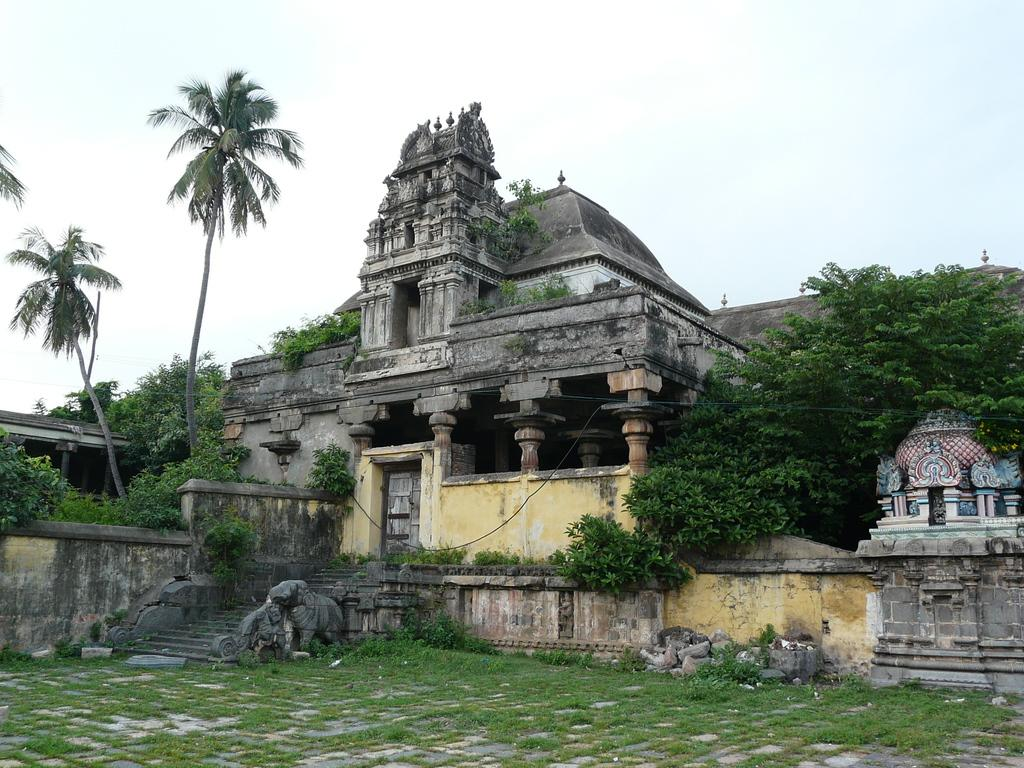What type of structure is in the picture? There is a temple in the picture. What can be seen in the foreground of the image? There is green grass in the foreground. What other natural elements are present in the picture? There are trees in the picture. What is visible in the sky? There are clouds in the sky. How many boats are visible in the picture? There are no boats present in the picture; it features a temple, green grass, trees, and clouds. What type of toothpaste is being used by the temple in the picture? There is no toothpaste present in the picture, as it is a scene featuring a temple, green grass, trees, and clouds. 